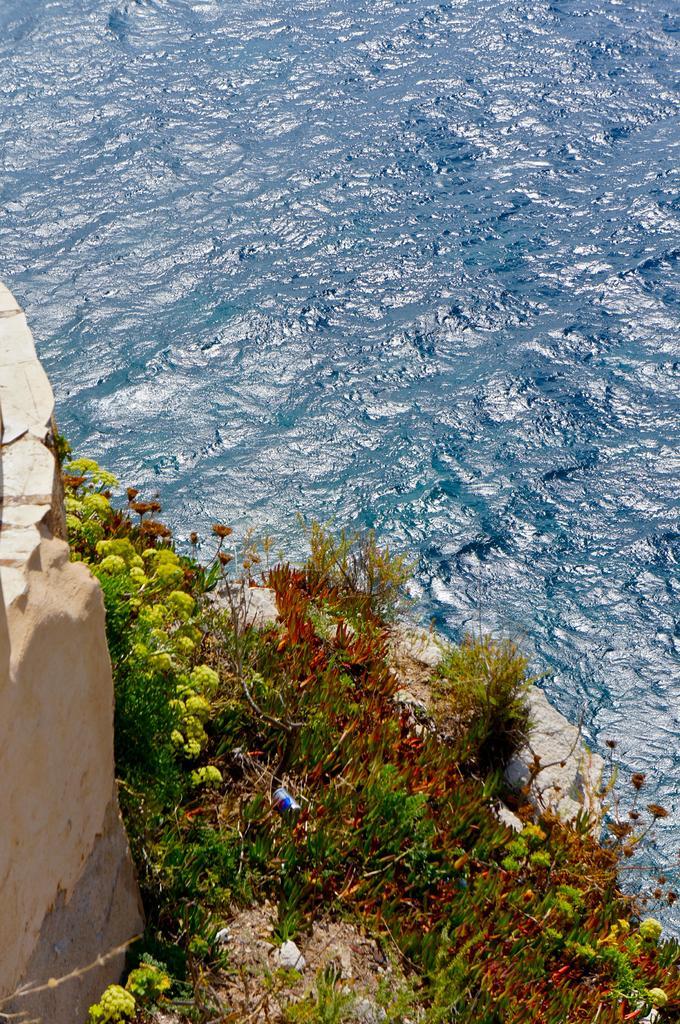How would you summarize this image in a sentence or two? In the picture we can see the water, which is blue in color and beside it, we can see a surface with different kings of plants and a wall. 